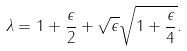Convert formula to latex. <formula><loc_0><loc_0><loc_500><loc_500>\lambda = 1 + \frac { \epsilon } { 2 } + \sqrt { \epsilon } \sqrt { 1 + \frac { \epsilon } { 4 } } .</formula> 